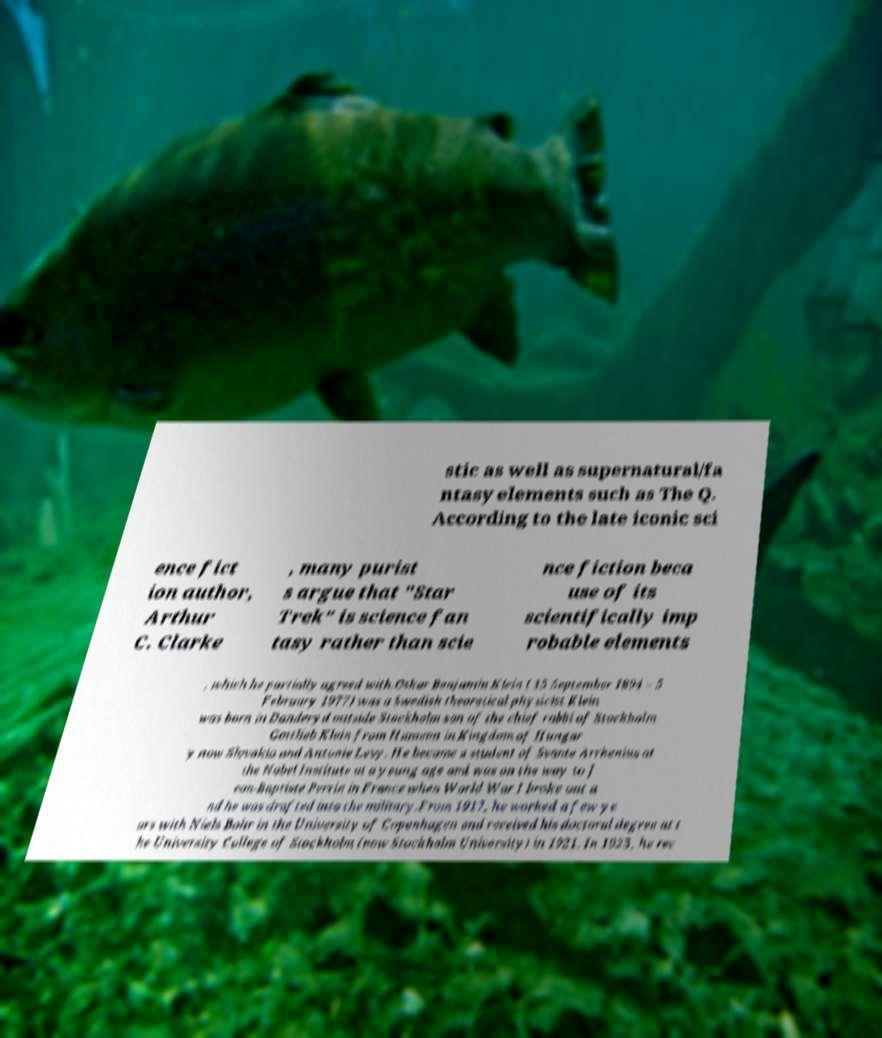Could you extract and type out the text from this image? stic as well as supernatural/fa ntasy elements such as The Q. According to the late iconic sci ence fict ion author, Arthur C. Clarke , many purist s argue that "Star Trek" is science fan tasy rather than scie nce fiction beca use of its scientifically imp robable elements , which he partially agreed with.Oskar Benjamin Klein ( 15 September 1894 – 5 February 1977) was a Swedish theoretical physicist.Klein was born in Danderyd outside Stockholm son of the chief rabbi of Stockholm Gottlieb Klein from Humenn in Kingdom of Hungar y now Slovakia and Antonie Levy. He became a student of Svante Arrhenius at the Nobel Institute at a young age and was on the way to J ean-Baptiste Perrin in France when World War I broke out a nd he was drafted into the military.From 1917, he worked a few ye ars with Niels Bohr in the University of Copenhagen and received his doctoral degree at t he University College of Stockholm (now Stockholm University) in 1921. In 1923, he rec 